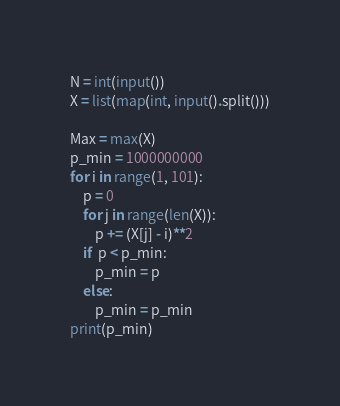Convert code to text. <code><loc_0><loc_0><loc_500><loc_500><_Python_>N = int(input())
X = list(map(int, input().split()))

Max = max(X)
p_min = 1000000000
for i in range(1, 101):
    p = 0
    for j in range(len(X)):
        p += (X[j] - i)**2
    if  p < p_min:
        p_min = p
    else:
        p_min = p_min
print(p_min)
</code> 